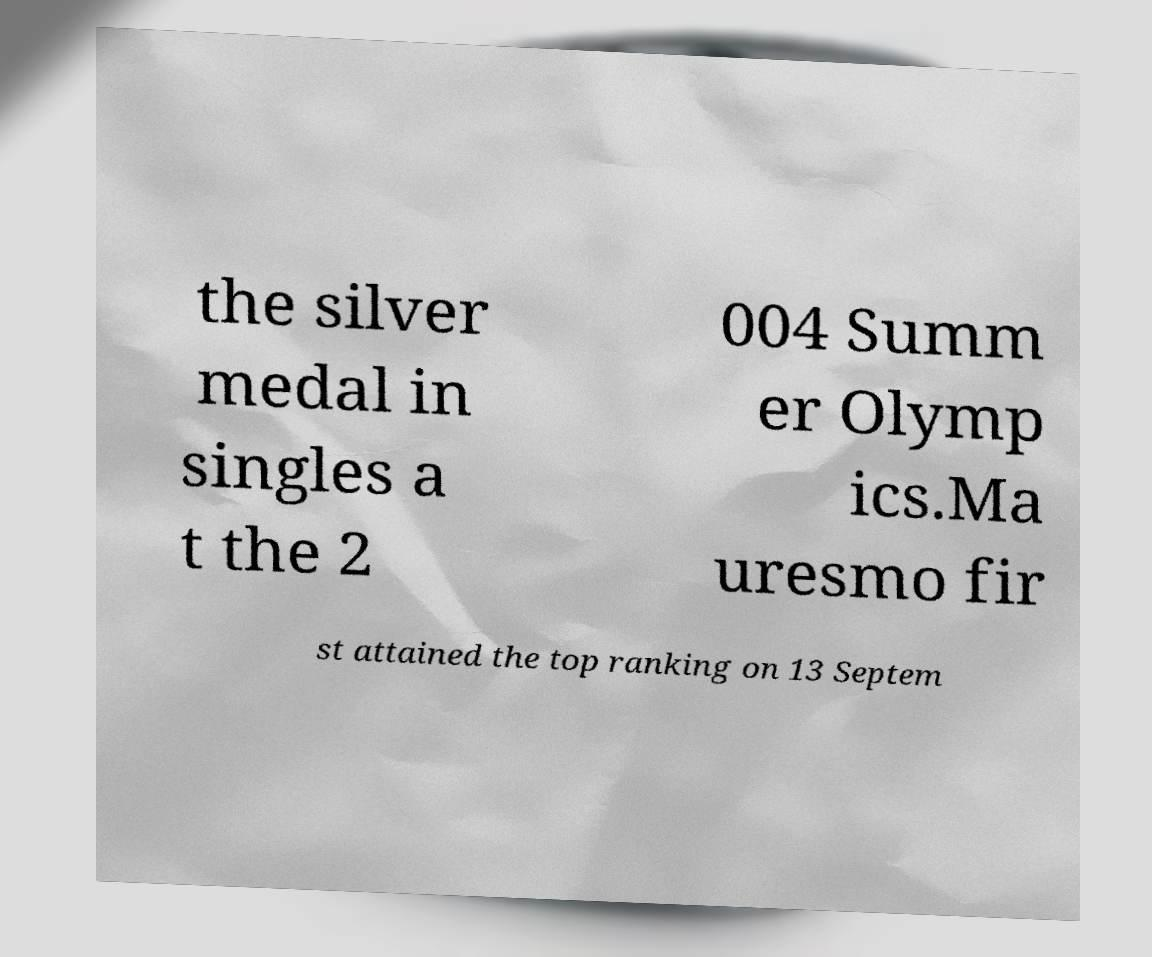Can you read and provide the text displayed in the image?This photo seems to have some interesting text. Can you extract and type it out for me? the silver medal in singles a t the 2 004 Summ er Olymp ics.Ma uresmo fir st attained the top ranking on 13 Septem 